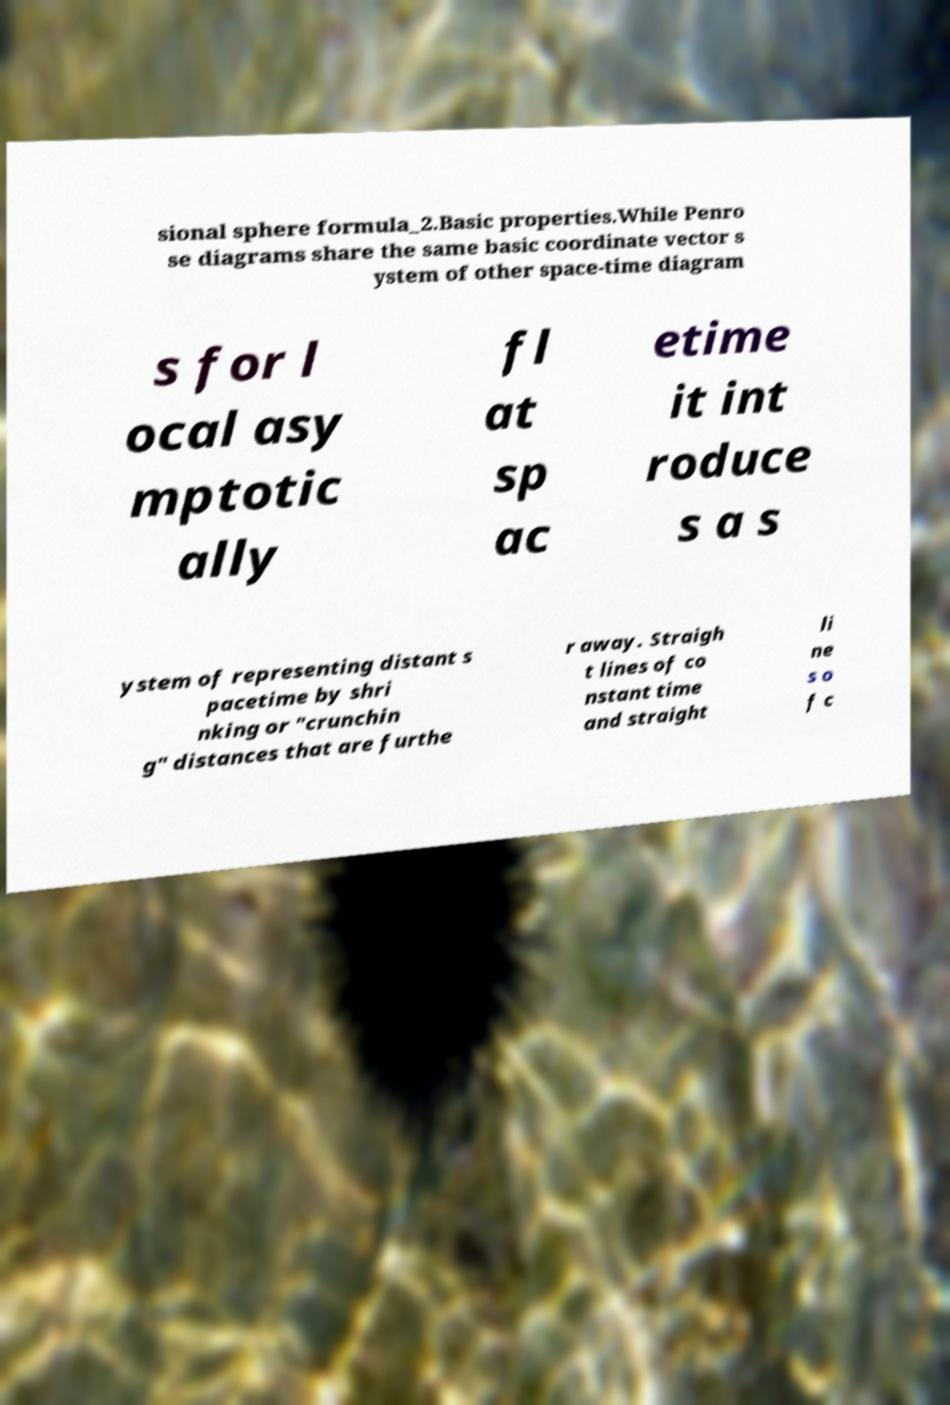I need the written content from this picture converted into text. Can you do that? sional sphere formula_2.Basic properties.While Penro se diagrams share the same basic coordinate vector s ystem of other space-time diagram s for l ocal asy mptotic ally fl at sp ac etime it int roduce s a s ystem of representing distant s pacetime by shri nking or "crunchin g" distances that are furthe r away. Straigh t lines of co nstant time and straight li ne s o f c 